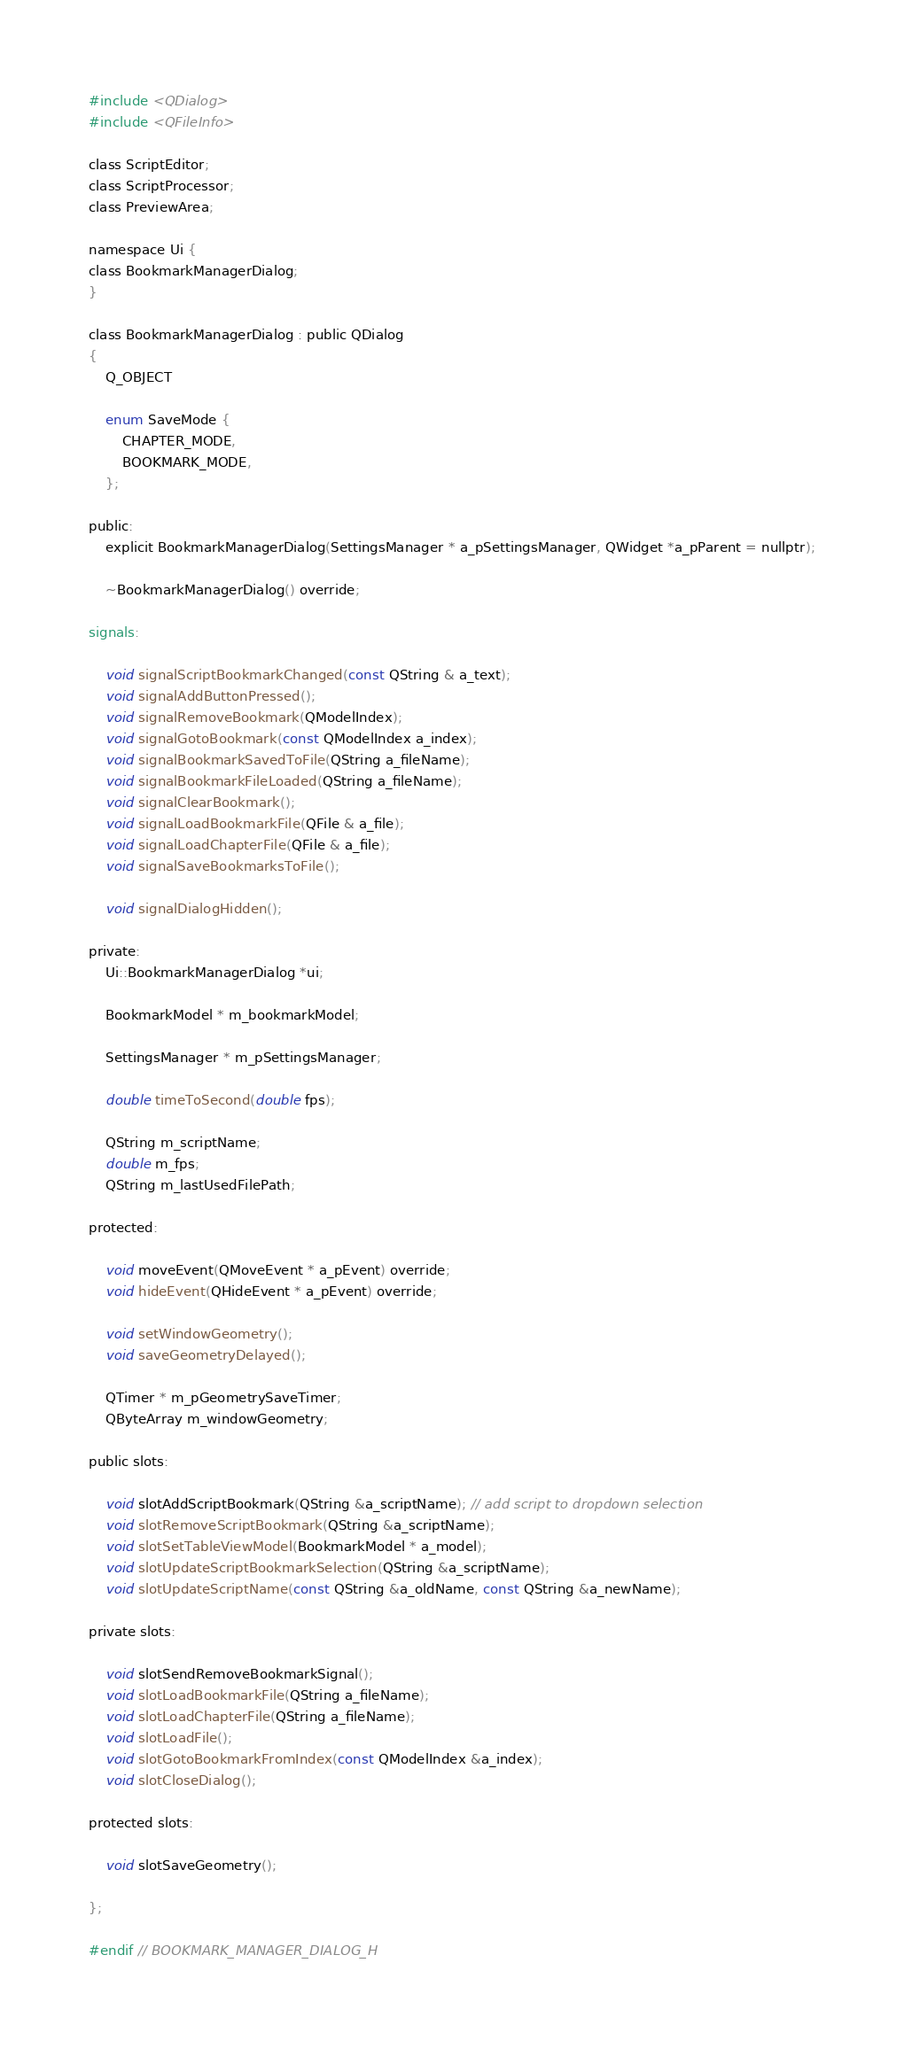Convert code to text. <code><loc_0><loc_0><loc_500><loc_500><_C_>
#include <QDialog>
#include <QFileInfo>

class ScriptEditor;
class ScriptProcessor;
class PreviewArea;

namespace Ui {
class BookmarkManagerDialog;
}

class BookmarkManagerDialog : public QDialog
{
    Q_OBJECT

    enum SaveMode {
        CHAPTER_MODE,
        BOOKMARK_MODE,
    };

public:
    explicit BookmarkManagerDialog(SettingsManager * a_pSettingsManager, QWidget *a_pParent = nullptr);

    ~BookmarkManagerDialog() override;

signals:

    void signalScriptBookmarkChanged(const QString & a_text);
    void signalAddButtonPressed();
    void signalRemoveBookmark(QModelIndex);
    void signalGotoBookmark(const QModelIndex a_index);
    void signalBookmarkSavedToFile(QString a_fileName);
    void signalBookmarkFileLoaded(QString a_fileName);
    void signalClearBookmark();
    void signalLoadBookmarkFile(QFile & a_file);
    void signalLoadChapterFile(QFile & a_file);
    void signalSaveBookmarksToFile();

    void signalDialogHidden();

private:
    Ui::BookmarkManagerDialog *ui;

    BookmarkModel * m_bookmarkModel;

    SettingsManager * m_pSettingsManager;

    double timeToSecond(double fps);

    QString m_scriptName;
    double m_fps;
    QString m_lastUsedFilePath;

protected:

    void moveEvent(QMoveEvent * a_pEvent) override;
    void hideEvent(QHideEvent * a_pEvent) override;

    void setWindowGeometry();
    void saveGeometryDelayed();

    QTimer * m_pGeometrySaveTimer;
    QByteArray m_windowGeometry;

public slots:

    void slotAddScriptBookmark(QString &a_scriptName); // add script to dropdown selection
    void slotRemoveScriptBookmark(QString &a_scriptName);
    void slotSetTableViewModel(BookmarkModel * a_model);
    void slotUpdateScriptBookmarkSelection(QString &a_scriptName);
    void slotUpdateScriptName(const QString &a_oldName, const QString &a_newName);

private slots:

    void slotSendRemoveBookmarkSignal();
    void slotLoadBookmarkFile(QString a_fileName);
    void slotLoadChapterFile(QString a_fileName);
    void slotLoadFile();
    void slotGotoBookmarkFromIndex(const QModelIndex &a_index);
    void slotCloseDialog();

protected slots:

    void slotSaveGeometry();

};

#endif // BOOKMARK_MANAGER_DIALOG_H
</code> 